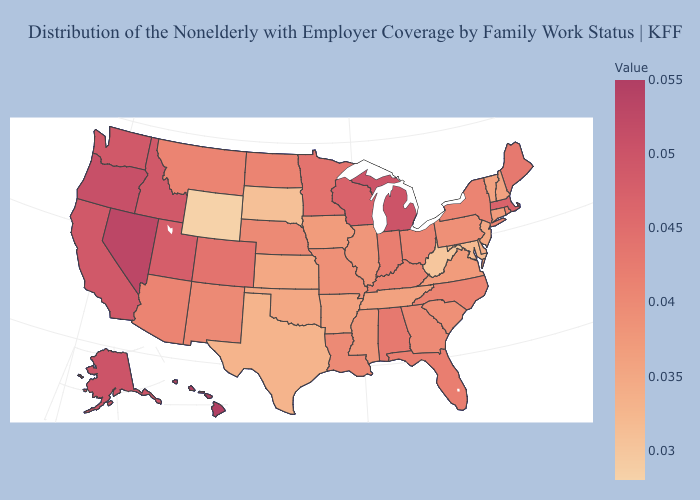Which states have the lowest value in the USA?
Keep it brief. Wyoming. Does Hawaii have the highest value in the USA?
Concise answer only. Yes. Does Hawaii have the highest value in the USA?
Answer briefly. Yes. Among the states that border Massachusetts , which have the highest value?
Concise answer only. New York, Rhode Island. Does Idaho have the lowest value in the USA?
Concise answer only. No. 